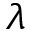<formula> <loc_0><loc_0><loc_500><loc_500>\lambda</formula> 